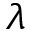<formula> <loc_0><loc_0><loc_500><loc_500>\lambda</formula> 